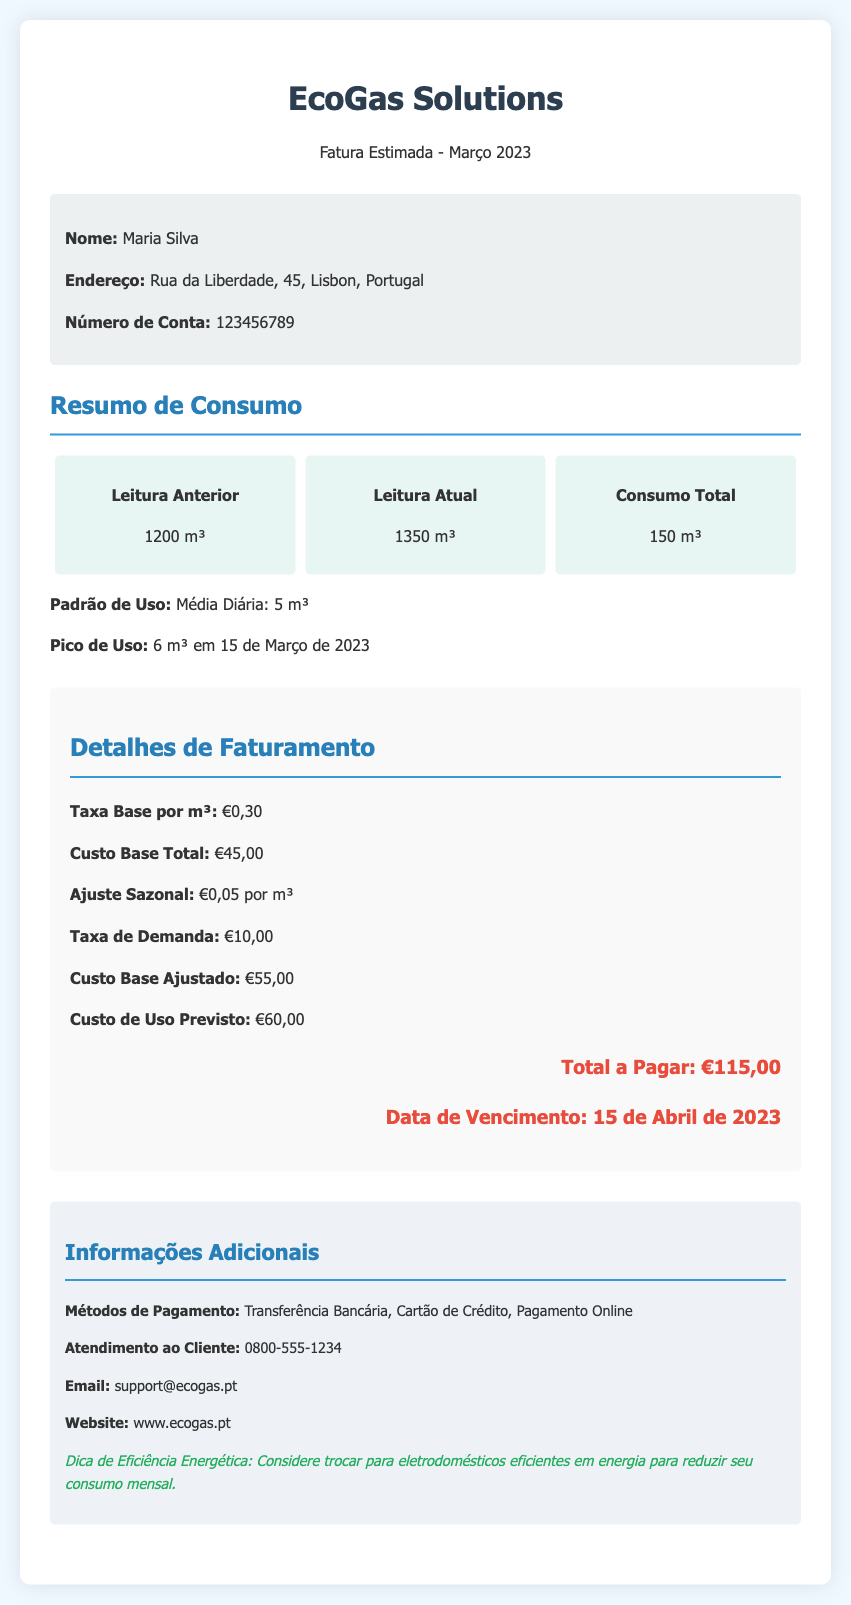What is the name of the customer? The name of the customer is listed in the document under customer information.
Answer: Maria Silva What is the address of the customer? The address of the customer is provided in the customer information section of the document.
Answer: Rua da Liberdade, 45, Lisbon, Portugal What is the total consumption for March 2023? The total consumption is summarized in the usage section, based on the previous and current readings.
Answer: 150 m³ What is the peak usage recorded? The peak usage is indicated within the summary of consumption in the document.
Answer: 6 m³ em 15 de Março de 2023 What is the total amount due for this bill? The total amount due is clearly stated in the billing details section as the final amount payable.
Answer: €115,00 What is the base rate per cubic meter? The base rate per cubic meter is detailed in the billing details.
Answer: €0,30 When is the payment due date? The payment due date is mentioned in the billing details section of the document.
Answer: 15 de Abril de 2023 What additional payment methods are available? The document lists the payment methods in the additional information section.
Answer: Transferência Bancária, Cartão de Crédito, Pagamento Online What is the customer's account number? The customer's account number is found within the customer information section of the document.
Answer: 123456789 